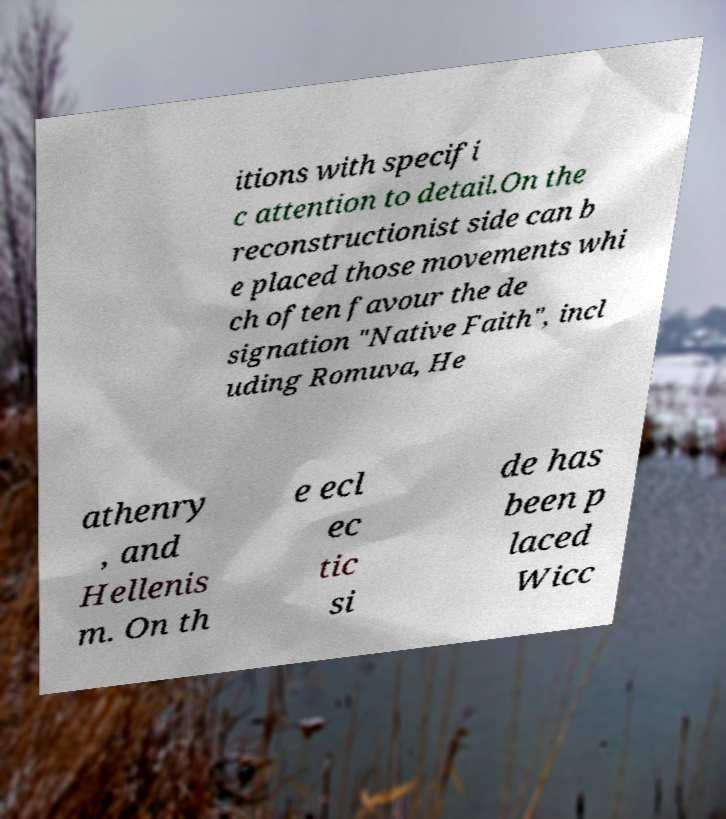Can you read and provide the text displayed in the image?This photo seems to have some interesting text. Can you extract and type it out for me? itions with specifi c attention to detail.On the reconstructionist side can b e placed those movements whi ch often favour the de signation "Native Faith", incl uding Romuva, He athenry , and Hellenis m. On th e ecl ec tic si de has been p laced Wicc 